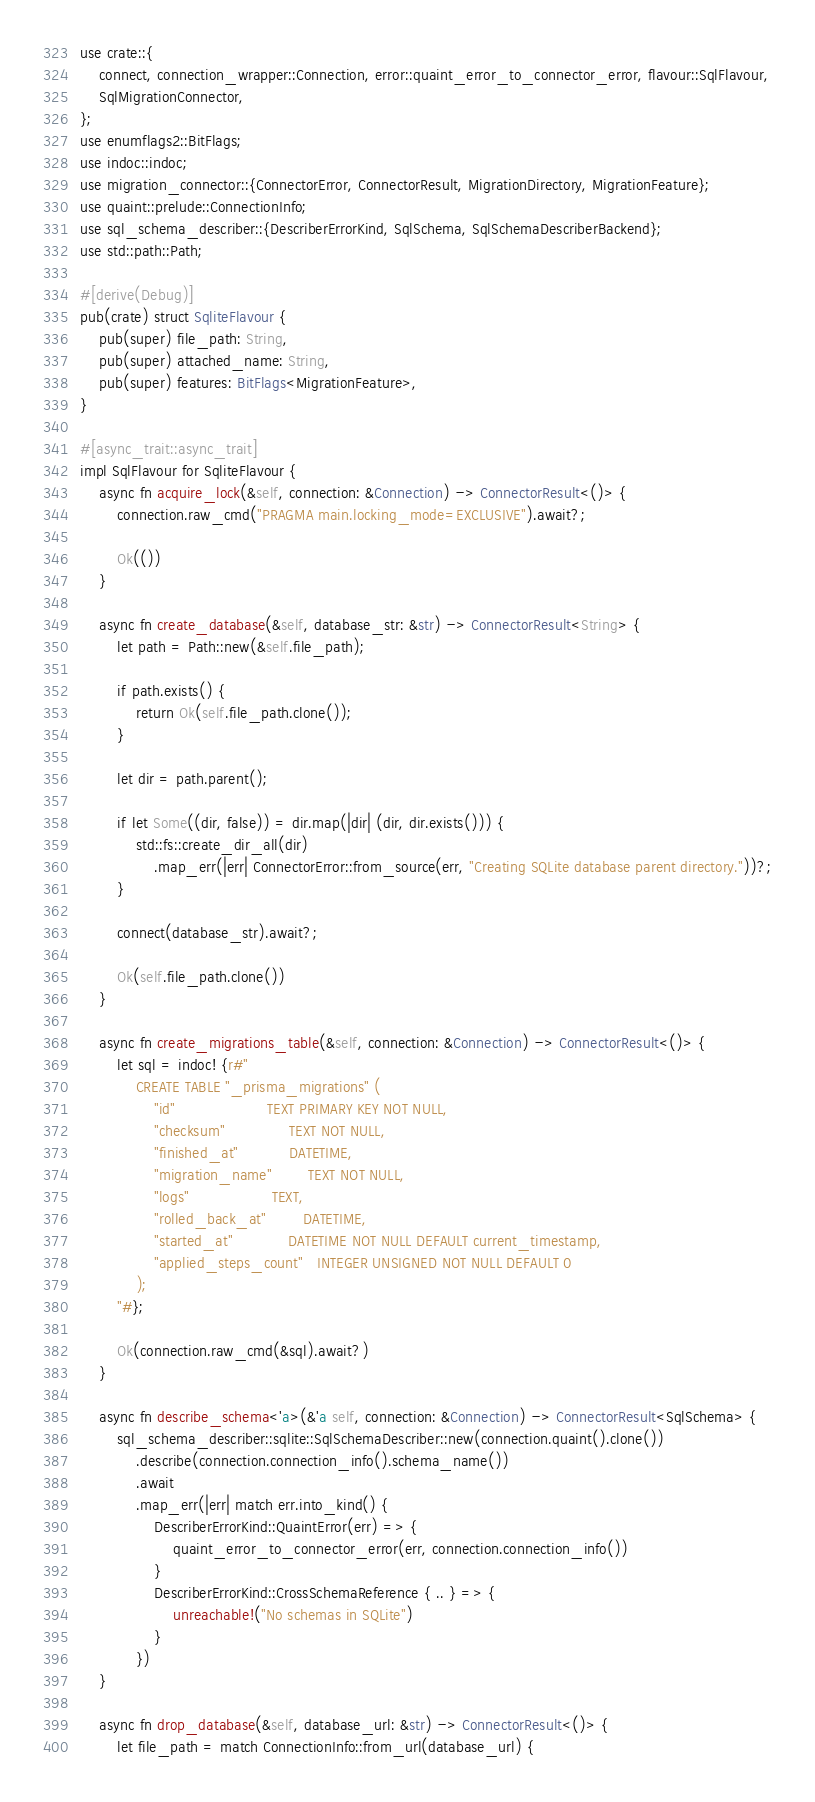<code> <loc_0><loc_0><loc_500><loc_500><_Rust_>use crate::{
    connect, connection_wrapper::Connection, error::quaint_error_to_connector_error, flavour::SqlFlavour,
    SqlMigrationConnector,
};
use enumflags2::BitFlags;
use indoc::indoc;
use migration_connector::{ConnectorError, ConnectorResult, MigrationDirectory, MigrationFeature};
use quaint::prelude::ConnectionInfo;
use sql_schema_describer::{DescriberErrorKind, SqlSchema, SqlSchemaDescriberBackend};
use std::path::Path;

#[derive(Debug)]
pub(crate) struct SqliteFlavour {
    pub(super) file_path: String,
    pub(super) attached_name: String,
    pub(super) features: BitFlags<MigrationFeature>,
}

#[async_trait::async_trait]
impl SqlFlavour for SqliteFlavour {
    async fn acquire_lock(&self, connection: &Connection) -> ConnectorResult<()> {
        connection.raw_cmd("PRAGMA main.locking_mode=EXCLUSIVE").await?;

        Ok(())
    }

    async fn create_database(&self, database_str: &str) -> ConnectorResult<String> {
        let path = Path::new(&self.file_path);

        if path.exists() {
            return Ok(self.file_path.clone());
        }

        let dir = path.parent();

        if let Some((dir, false)) = dir.map(|dir| (dir, dir.exists())) {
            std::fs::create_dir_all(dir)
                .map_err(|err| ConnectorError::from_source(err, "Creating SQLite database parent directory."))?;
        }

        connect(database_str).await?;

        Ok(self.file_path.clone())
    }

    async fn create_migrations_table(&self, connection: &Connection) -> ConnectorResult<()> {
        let sql = indoc! {r#"
            CREATE TABLE "_prisma_migrations" (
                "id"                    TEXT PRIMARY KEY NOT NULL,
                "checksum"              TEXT NOT NULL,
                "finished_at"           DATETIME,
                "migration_name"        TEXT NOT NULL,
                "logs"                  TEXT,
                "rolled_back_at"        DATETIME,
                "started_at"            DATETIME NOT NULL DEFAULT current_timestamp,
                "applied_steps_count"   INTEGER UNSIGNED NOT NULL DEFAULT 0
            );
        "#};

        Ok(connection.raw_cmd(&sql).await?)
    }

    async fn describe_schema<'a>(&'a self, connection: &Connection) -> ConnectorResult<SqlSchema> {
        sql_schema_describer::sqlite::SqlSchemaDescriber::new(connection.quaint().clone())
            .describe(connection.connection_info().schema_name())
            .await
            .map_err(|err| match err.into_kind() {
                DescriberErrorKind::QuaintError(err) => {
                    quaint_error_to_connector_error(err, connection.connection_info())
                }
                DescriberErrorKind::CrossSchemaReference { .. } => {
                    unreachable!("No schemas in SQLite")
                }
            })
    }

    async fn drop_database(&self, database_url: &str) -> ConnectorResult<()> {
        let file_path = match ConnectionInfo::from_url(database_url) {</code> 